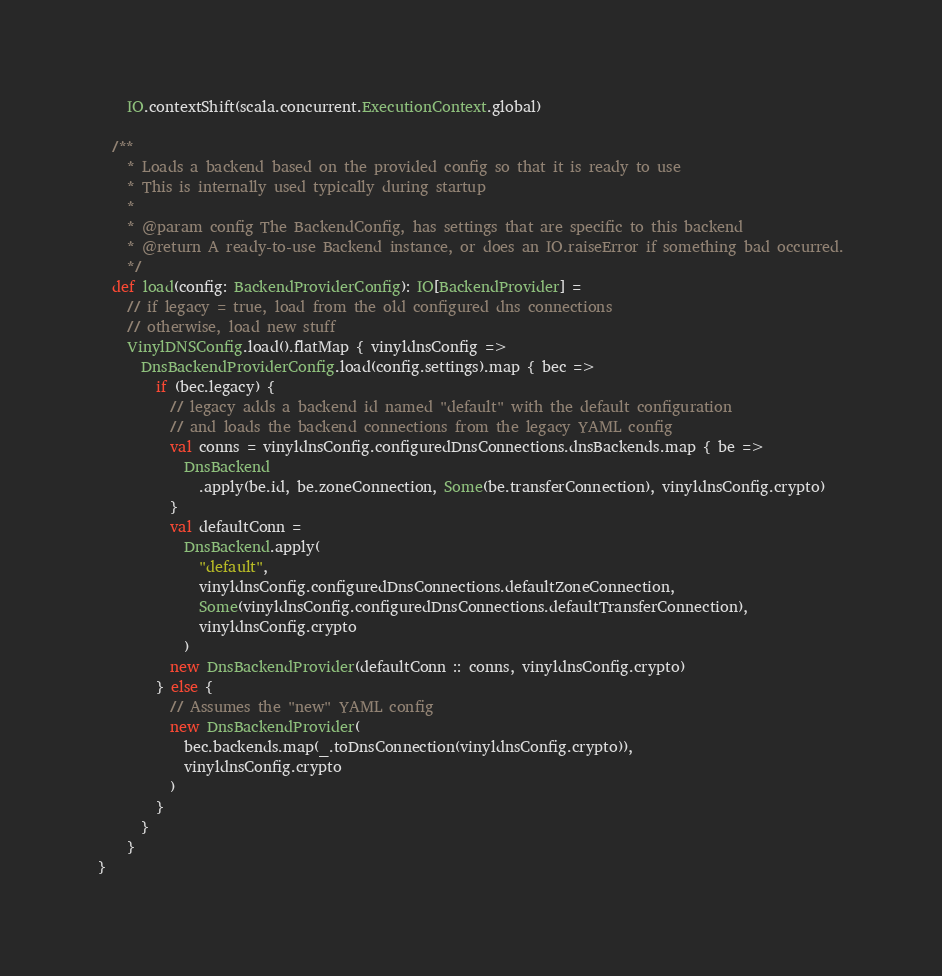Convert code to text. <code><loc_0><loc_0><loc_500><loc_500><_Scala_>    IO.contextShift(scala.concurrent.ExecutionContext.global)

  /**
    * Loads a backend based on the provided config so that it is ready to use
    * This is internally used typically during startup
    *
    * @param config The BackendConfig, has settings that are specific to this backend
    * @return A ready-to-use Backend instance, or does an IO.raiseError if something bad occurred.
    */
  def load(config: BackendProviderConfig): IO[BackendProvider] =
    // if legacy = true, load from the old configured dns connections
    // otherwise, load new stuff
    VinylDNSConfig.load().flatMap { vinyldnsConfig =>
      DnsBackendProviderConfig.load(config.settings).map { bec =>
        if (bec.legacy) {
          // legacy adds a backend id named "default" with the default configuration
          // and loads the backend connections from the legacy YAML config
          val conns = vinyldnsConfig.configuredDnsConnections.dnsBackends.map { be =>
            DnsBackend
              .apply(be.id, be.zoneConnection, Some(be.transferConnection), vinyldnsConfig.crypto)
          }
          val defaultConn =
            DnsBackend.apply(
              "default",
              vinyldnsConfig.configuredDnsConnections.defaultZoneConnection,
              Some(vinyldnsConfig.configuredDnsConnections.defaultTransferConnection),
              vinyldnsConfig.crypto
            )
          new DnsBackendProvider(defaultConn :: conns, vinyldnsConfig.crypto)
        } else {
          // Assumes the "new" YAML config
          new DnsBackendProvider(
            bec.backends.map(_.toDnsConnection(vinyldnsConfig.crypto)),
            vinyldnsConfig.crypto
          )
        }
      }
    }
}
</code> 